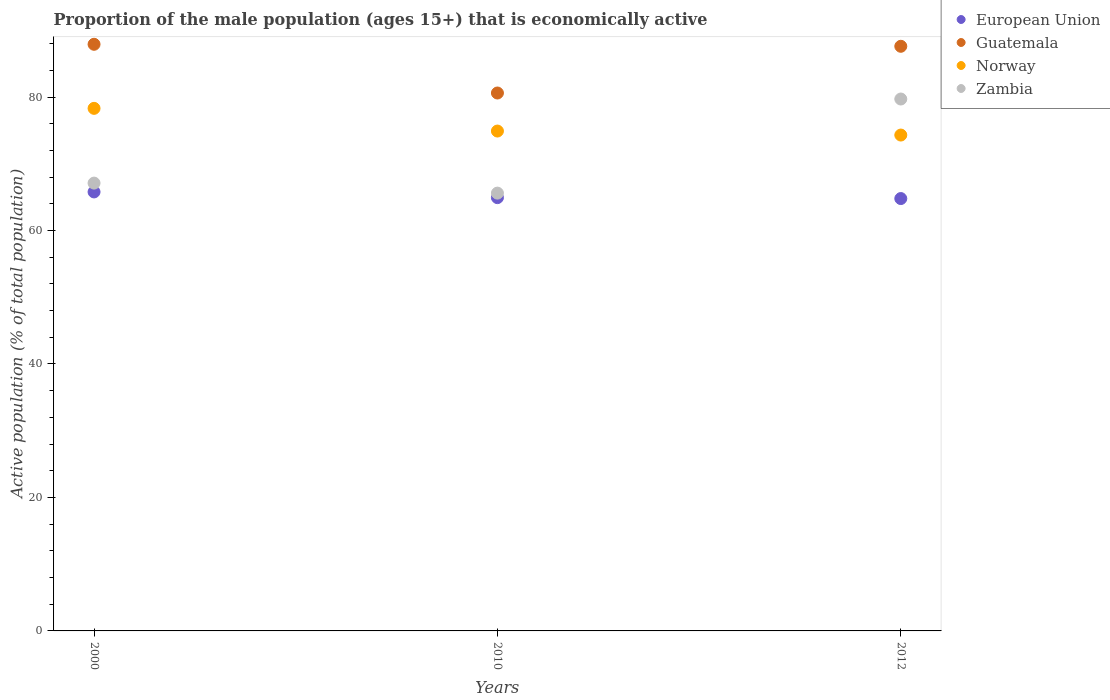Is the number of dotlines equal to the number of legend labels?
Offer a terse response. Yes. What is the proportion of the male population that is economically active in Guatemala in 2000?
Provide a succinct answer. 87.9. Across all years, what is the maximum proportion of the male population that is economically active in Guatemala?
Offer a very short reply. 87.9. Across all years, what is the minimum proportion of the male population that is economically active in European Union?
Your response must be concise. 64.78. In which year was the proportion of the male population that is economically active in European Union maximum?
Offer a very short reply. 2000. In which year was the proportion of the male population that is economically active in Zambia minimum?
Your answer should be very brief. 2010. What is the total proportion of the male population that is economically active in Guatemala in the graph?
Keep it short and to the point. 256.1. What is the difference between the proportion of the male population that is economically active in Norway in 2010 and that in 2012?
Offer a very short reply. 0.6. What is the difference between the proportion of the male population that is economically active in Norway in 2012 and the proportion of the male population that is economically active in Zambia in 2010?
Your answer should be very brief. 8.7. What is the average proportion of the male population that is economically active in European Union per year?
Your answer should be very brief. 65.16. In the year 2012, what is the difference between the proportion of the male population that is economically active in Zambia and proportion of the male population that is economically active in Guatemala?
Your answer should be compact. -7.9. What is the ratio of the proportion of the male population that is economically active in Guatemala in 2000 to that in 2012?
Your answer should be compact. 1. What is the difference between the highest and the second highest proportion of the male population that is economically active in European Union?
Your answer should be compact. 0.86. What is the difference between the highest and the lowest proportion of the male population that is economically active in Zambia?
Provide a succinct answer. 14.1. In how many years, is the proportion of the male population that is economically active in European Union greater than the average proportion of the male population that is economically active in European Union taken over all years?
Offer a very short reply. 1. Is the sum of the proportion of the male population that is economically active in Guatemala in 2000 and 2012 greater than the maximum proportion of the male population that is economically active in Zambia across all years?
Provide a short and direct response. Yes. Is it the case that in every year, the sum of the proportion of the male population that is economically active in European Union and proportion of the male population that is economically active in Zambia  is greater than the sum of proportion of the male population that is economically active in Guatemala and proportion of the male population that is economically active in Norway?
Provide a succinct answer. No. Is the proportion of the male population that is economically active in Guatemala strictly greater than the proportion of the male population that is economically active in European Union over the years?
Your answer should be compact. Yes. How many dotlines are there?
Provide a succinct answer. 4. How are the legend labels stacked?
Keep it short and to the point. Vertical. What is the title of the graph?
Offer a terse response. Proportion of the male population (ages 15+) that is economically active. What is the label or title of the X-axis?
Your answer should be very brief. Years. What is the label or title of the Y-axis?
Give a very brief answer. Active population (% of total population). What is the Active population (% of total population) in European Union in 2000?
Keep it short and to the point. 65.78. What is the Active population (% of total population) in Guatemala in 2000?
Make the answer very short. 87.9. What is the Active population (% of total population) of Norway in 2000?
Provide a short and direct response. 78.3. What is the Active population (% of total population) in Zambia in 2000?
Your answer should be compact. 67.1. What is the Active population (% of total population) in European Union in 2010?
Ensure brevity in your answer.  64.92. What is the Active population (% of total population) of Guatemala in 2010?
Give a very brief answer. 80.6. What is the Active population (% of total population) in Norway in 2010?
Offer a very short reply. 74.9. What is the Active population (% of total population) of Zambia in 2010?
Provide a short and direct response. 65.6. What is the Active population (% of total population) of European Union in 2012?
Make the answer very short. 64.78. What is the Active population (% of total population) in Guatemala in 2012?
Offer a terse response. 87.6. What is the Active population (% of total population) of Norway in 2012?
Make the answer very short. 74.3. What is the Active population (% of total population) of Zambia in 2012?
Your response must be concise. 79.7. Across all years, what is the maximum Active population (% of total population) of European Union?
Provide a short and direct response. 65.78. Across all years, what is the maximum Active population (% of total population) of Guatemala?
Offer a terse response. 87.9. Across all years, what is the maximum Active population (% of total population) of Norway?
Keep it short and to the point. 78.3. Across all years, what is the maximum Active population (% of total population) in Zambia?
Offer a terse response. 79.7. Across all years, what is the minimum Active population (% of total population) in European Union?
Your answer should be compact. 64.78. Across all years, what is the minimum Active population (% of total population) of Guatemala?
Your answer should be very brief. 80.6. Across all years, what is the minimum Active population (% of total population) in Norway?
Offer a terse response. 74.3. Across all years, what is the minimum Active population (% of total population) of Zambia?
Your response must be concise. 65.6. What is the total Active population (% of total population) in European Union in the graph?
Your answer should be compact. 195.48. What is the total Active population (% of total population) in Guatemala in the graph?
Keep it short and to the point. 256.1. What is the total Active population (% of total population) of Norway in the graph?
Give a very brief answer. 227.5. What is the total Active population (% of total population) in Zambia in the graph?
Offer a very short reply. 212.4. What is the difference between the Active population (% of total population) of European Union in 2000 and that in 2010?
Offer a very short reply. 0.86. What is the difference between the Active population (% of total population) in Guatemala in 2000 and that in 2010?
Ensure brevity in your answer.  7.3. What is the difference between the Active population (% of total population) of Norway in 2000 and that in 2010?
Ensure brevity in your answer.  3.4. What is the difference between the Active population (% of total population) of Zambia in 2000 and that in 2010?
Give a very brief answer. 1.5. What is the difference between the Active population (% of total population) of Zambia in 2000 and that in 2012?
Your answer should be compact. -12.6. What is the difference between the Active population (% of total population) of European Union in 2010 and that in 2012?
Offer a very short reply. 0.14. What is the difference between the Active population (% of total population) in Zambia in 2010 and that in 2012?
Your answer should be compact. -14.1. What is the difference between the Active population (% of total population) of European Union in 2000 and the Active population (% of total population) of Guatemala in 2010?
Provide a succinct answer. -14.82. What is the difference between the Active population (% of total population) of European Union in 2000 and the Active population (% of total population) of Norway in 2010?
Offer a terse response. -9.12. What is the difference between the Active population (% of total population) of European Union in 2000 and the Active population (% of total population) of Zambia in 2010?
Give a very brief answer. 0.18. What is the difference between the Active population (% of total population) in Guatemala in 2000 and the Active population (% of total population) in Zambia in 2010?
Keep it short and to the point. 22.3. What is the difference between the Active population (% of total population) of Norway in 2000 and the Active population (% of total population) of Zambia in 2010?
Ensure brevity in your answer.  12.7. What is the difference between the Active population (% of total population) in European Union in 2000 and the Active population (% of total population) in Guatemala in 2012?
Provide a short and direct response. -21.82. What is the difference between the Active population (% of total population) of European Union in 2000 and the Active population (% of total population) of Norway in 2012?
Your response must be concise. -8.52. What is the difference between the Active population (% of total population) in European Union in 2000 and the Active population (% of total population) in Zambia in 2012?
Provide a succinct answer. -13.92. What is the difference between the Active population (% of total population) in Guatemala in 2000 and the Active population (% of total population) in Zambia in 2012?
Ensure brevity in your answer.  8.2. What is the difference between the Active population (% of total population) of European Union in 2010 and the Active population (% of total population) of Guatemala in 2012?
Provide a short and direct response. -22.68. What is the difference between the Active population (% of total population) of European Union in 2010 and the Active population (% of total population) of Norway in 2012?
Provide a succinct answer. -9.38. What is the difference between the Active population (% of total population) in European Union in 2010 and the Active population (% of total population) in Zambia in 2012?
Your response must be concise. -14.78. What is the difference between the Active population (% of total population) in Guatemala in 2010 and the Active population (% of total population) in Norway in 2012?
Offer a very short reply. 6.3. What is the difference between the Active population (% of total population) of Guatemala in 2010 and the Active population (% of total population) of Zambia in 2012?
Give a very brief answer. 0.9. What is the average Active population (% of total population) in European Union per year?
Make the answer very short. 65.16. What is the average Active population (% of total population) of Guatemala per year?
Make the answer very short. 85.37. What is the average Active population (% of total population) of Norway per year?
Your answer should be very brief. 75.83. What is the average Active population (% of total population) in Zambia per year?
Offer a terse response. 70.8. In the year 2000, what is the difference between the Active population (% of total population) of European Union and Active population (% of total population) of Guatemala?
Keep it short and to the point. -22.12. In the year 2000, what is the difference between the Active population (% of total population) of European Union and Active population (% of total population) of Norway?
Your answer should be very brief. -12.52. In the year 2000, what is the difference between the Active population (% of total population) of European Union and Active population (% of total population) of Zambia?
Your answer should be compact. -1.32. In the year 2000, what is the difference between the Active population (% of total population) of Guatemala and Active population (% of total population) of Zambia?
Provide a succinct answer. 20.8. In the year 2000, what is the difference between the Active population (% of total population) of Norway and Active population (% of total population) of Zambia?
Offer a terse response. 11.2. In the year 2010, what is the difference between the Active population (% of total population) in European Union and Active population (% of total population) in Guatemala?
Offer a very short reply. -15.68. In the year 2010, what is the difference between the Active population (% of total population) in European Union and Active population (% of total population) in Norway?
Make the answer very short. -9.98. In the year 2010, what is the difference between the Active population (% of total population) in European Union and Active population (% of total population) in Zambia?
Keep it short and to the point. -0.68. In the year 2010, what is the difference between the Active population (% of total population) of Guatemala and Active population (% of total population) of Zambia?
Your answer should be compact. 15. In the year 2010, what is the difference between the Active population (% of total population) of Norway and Active population (% of total population) of Zambia?
Your answer should be very brief. 9.3. In the year 2012, what is the difference between the Active population (% of total population) in European Union and Active population (% of total population) in Guatemala?
Your response must be concise. -22.82. In the year 2012, what is the difference between the Active population (% of total population) of European Union and Active population (% of total population) of Norway?
Keep it short and to the point. -9.52. In the year 2012, what is the difference between the Active population (% of total population) in European Union and Active population (% of total population) in Zambia?
Your response must be concise. -14.92. In the year 2012, what is the difference between the Active population (% of total population) in Guatemala and Active population (% of total population) in Norway?
Your response must be concise. 13.3. What is the ratio of the Active population (% of total population) in European Union in 2000 to that in 2010?
Offer a very short reply. 1.01. What is the ratio of the Active population (% of total population) of Guatemala in 2000 to that in 2010?
Your answer should be very brief. 1.09. What is the ratio of the Active population (% of total population) in Norway in 2000 to that in 2010?
Make the answer very short. 1.05. What is the ratio of the Active population (% of total population) of Zambia in 2000 to that in 2010?
Provide a short and direct response. 1.02. What is the ratio of the Active population (% of total population) of European Union in 2000 to that in 2012?
Your answer should be very brief. 1.02. What is the ratio of the Active population (% of total population) of Guatemala in 2000 to that in 2012?
Provide a short and direct response. 1. What is the ratio of the Active population (% of total population) in Norway in 2000 to that in 2012?
Keep it short and to the point. 1.05. What is the ratio of the Active population (% of total population) of Zambia in 2000 to that in 2012?
Your answer should be compact. 0.84. What is the ratio of the Active population (% of total population) of European Union in 2010 to that in 2012?
Your answer should be very brief. 1. What is the ratio of the Active population (% of total population) of Guatemala in 2010 to that in 2012?
Provide a succinct answer. 0.92. What is the ratio of the Active population (% of total population) in Norway in 2010 to that in 2012?
Keep it short and to the point. 1.01. What is the ratio of the Active population (% of total population) of Zambia in 2010 to that in 2012?
Ensure brevity in your answer.  0.82. What is the difference between the highest and the second highest Active population (% of total population) in European Union?
Provide a succinct answer. 0.86. What is the difference between the highest and the second highest Active population (% of total population) in Guatemala?
Your answer should be compact. 0.3. What is the difference between the highest and the second highest Active population (% of total population) in Norway?
Give a very brief answer. 3.4. What is the difference between the highest and the second highest Active population (% of total population) of Zambia?
Offer a terse response. 12.6. What is the difference between the highest and the lowest Active population (% of total population) in Norway?
Provide a short and direct response. 4. 